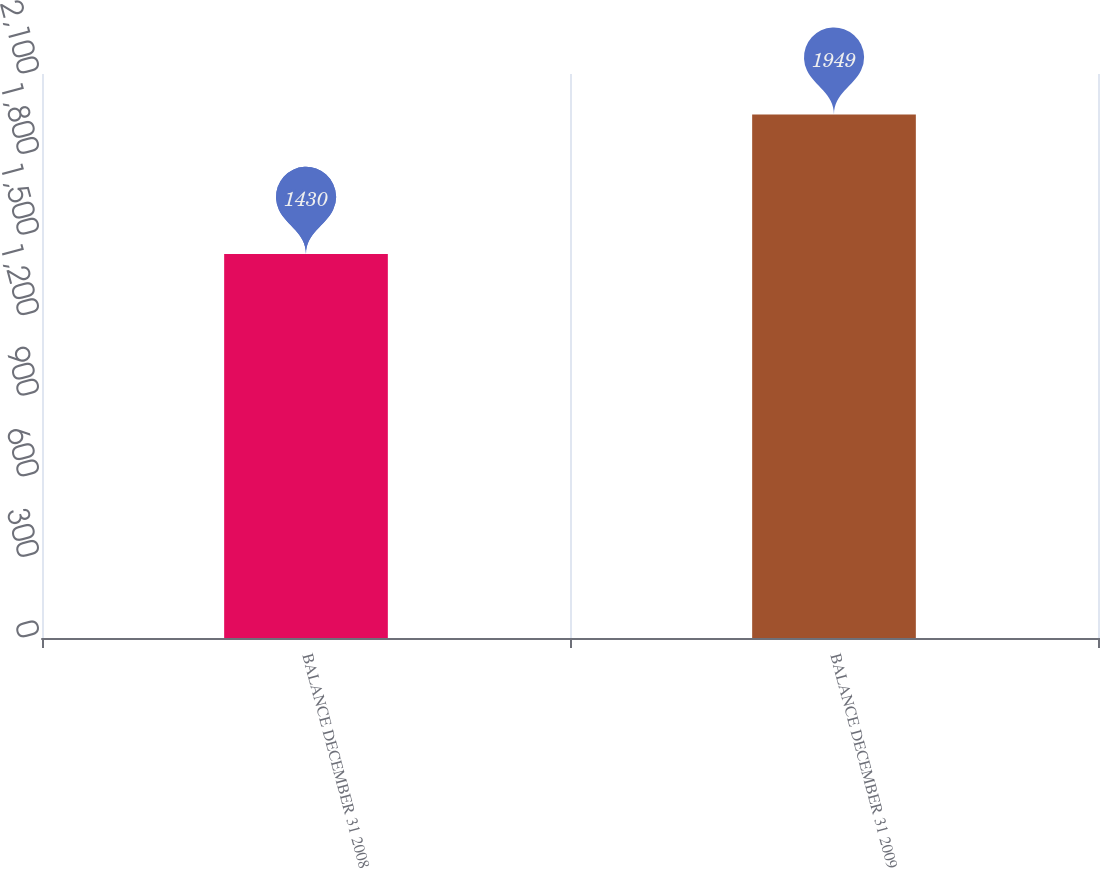<chart> <loc_0><loc_0><loc_500><loc_500><bar_chart><fcel>BALANCE DECEMBER 31 2008<fcel>BALANCE DECEMBER 31 2009<nl><fcel>1430<fcel>1949<nl></chart> 